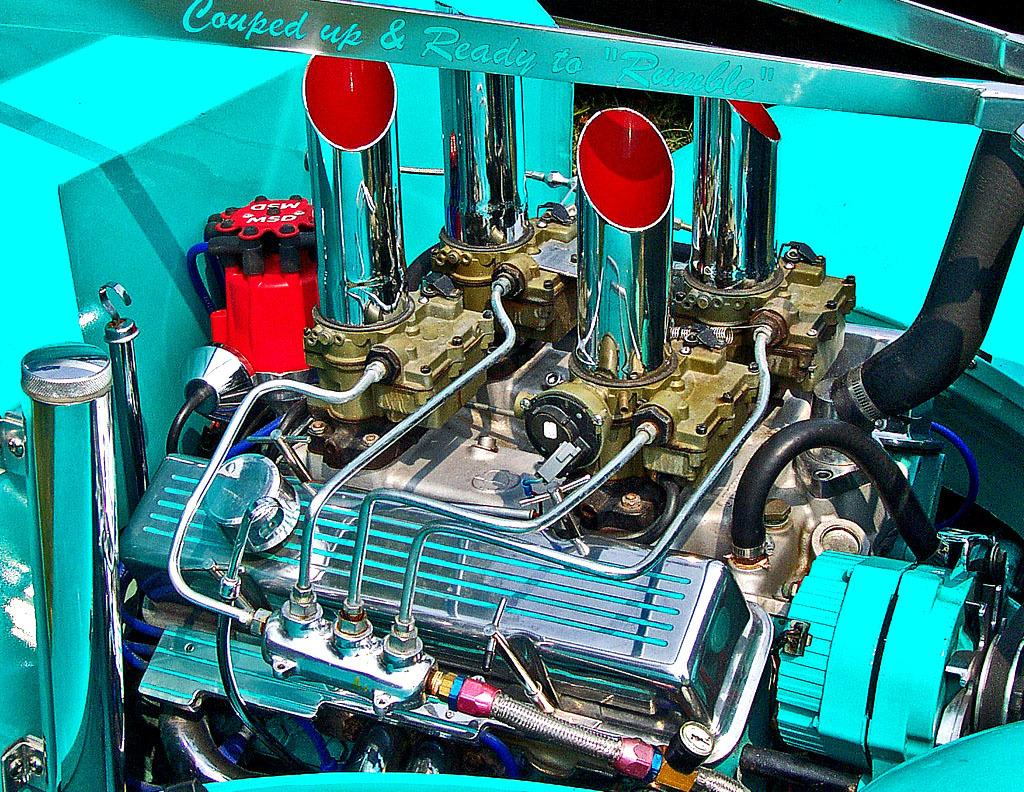What is the main subject of the picture? The main subject of the picture is an engine. Can you describe the colors of the engine? The engine has red and cyan color parts. What is the price of the engine in the image? The price of the engine is not mentioned in the image, so it cannot be determined. 